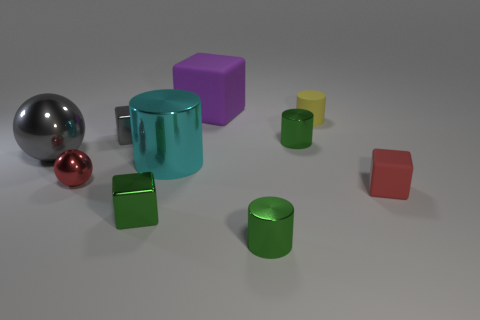Subtract all cylinders. How many objects are left? 6 Add 8 red objects. How many red objects exist? 10 Subtract 1 gray balls. How many objects are left? 9 Subtract all tiny gray cubes. Subtract all tiny metal objects. How many objects are left? 4 Add 6 tiny gray blocks. How many tiny gray blocks are left? 7 